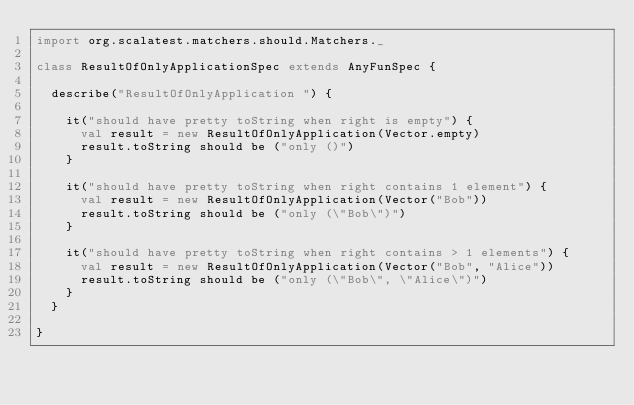<code> <loc_0><loc_0><loc_500><loc_500><_Scala_>import org.scalatest.matchers.should.Matchers._

class ResultOfOnlyApplicationSpec extends AnyFunSpec {
  
  describe("ResultOfOnlyApplication ") {
    
    it("should have pretty toString when right is empty") {
      val result = new ResultOfOnlyApplication(Vector.empty)
      result.toString should be ("only ()")
    }
    
    it("should have pretty toString when right contains 1 element") {
      val result = new ResultOfOnlyApplication(Vector("Bob"))
      result.toString should be ("only (\"Bob\")")
    }
    
    it("should have pretty toString when right contains > 1 elements") {
      val result = new ResultOfOnlyApplication(Vector("Bob", "Alice"))
      result.toString should be ("only (\"Bob\", \"Alice\")")
    }
  }
  
}
</code> 